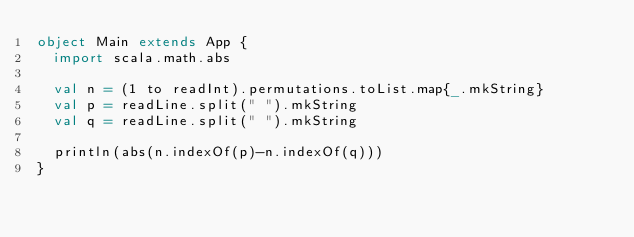Convert code to text. <code><loc_0><loc_0><loc_500><loc_500><_Scala_>object Main extends App {
  import scala.math.abs
  
  val n = (1 to readInt).permutations.toList.map{_.mkString}
  val p = readLine.split(" ").mkString
  val q = readLine.split(" ").mkString
  
  println(abs(n.indexOf(p)-n.indexOf(q)))
}</code> 